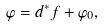<formula> <loc_0><loc_0><loc_500><loc_500>\varphi = d ^ { * } f + \varphi _ { 0 } ,</formula> 